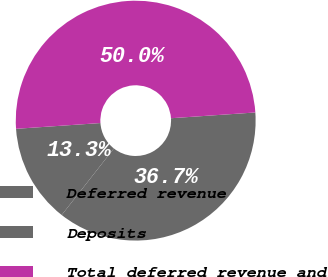<chart> <loc_0><loc_0><loc_500><loc_500><pie_chart><fcel>Deferred revenue<fcel>Deposits<fcel>Total deferred revenue and<nl><fcel>13.33%<fcel>36.67%<fcel>50.0%<nl></chart> 